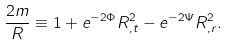Convert formula to latex. <formula><loc_0><loc_0><loc_500><loc_500>\frac { 2 m } { R } \equiv 1 + e ^ { - 2 \Phi } R _ { , t } ^ { 2 } - e ^ { - 2 \Psi } R _ { , r } ^ { 2 } .</formula> 